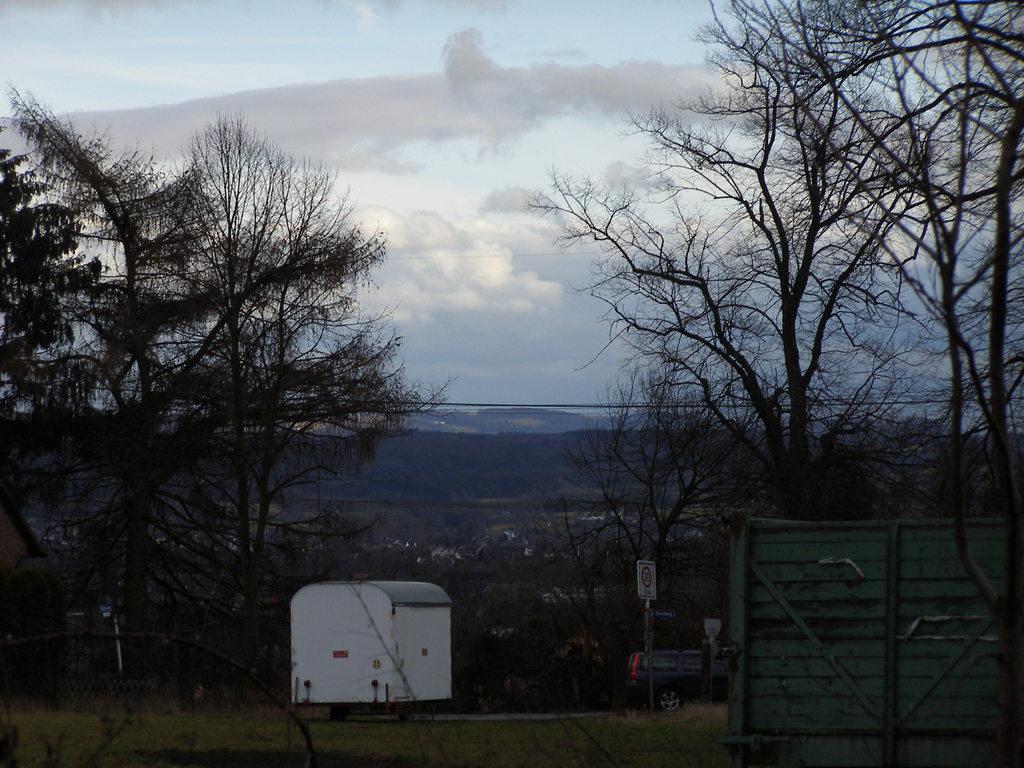How would you summarize this image in a sentence or two? In this image on the left and right side, I can see the trees. I can see a car. In the background, I can see the clouds and the sky. 